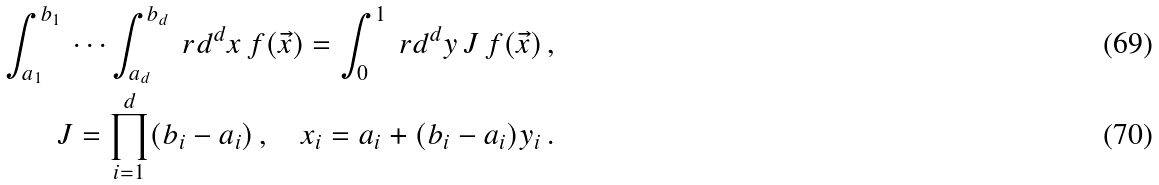Convert formula to latex. <formula><loc_0><loc_0><loc_500><loc_500>\int _ { a _ { 1 } } ^ { b _ { 1 } } \, \cdots \int _ { a _ { d } } ^ { b _ { d } } \ r d ^ { d } x \, f ( \vec { x } ) = \int _ { 0 } ^ { 1 } \ r d ^ { d } y \, J \, f ( \vec { x } ) \, , \\ J = \prod _ { i = 1 } ^ { d } ( b _ { i } - a _ { i } ) \, , \quad x _ { i } = a _ { i } + ( b _ { i } - a _ { i } ) y _ { i } \, .</formula> 